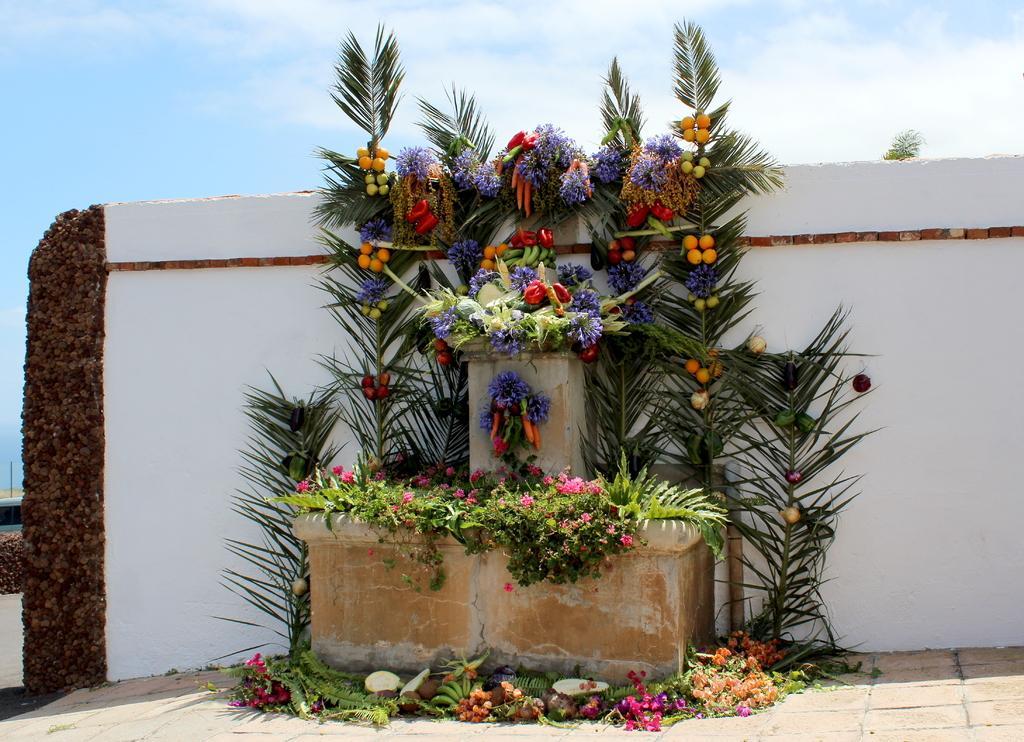How would you summarize this image in a sentence or two? This image is taken outdoors. At the top of the image there is the sky with clouds. At the bottom of the image there is a floor. In the middle of the image there is a wall and there is an inauguration stone decorated with a few plants and many flowers. There are a few leaves, fruits and flowers. 